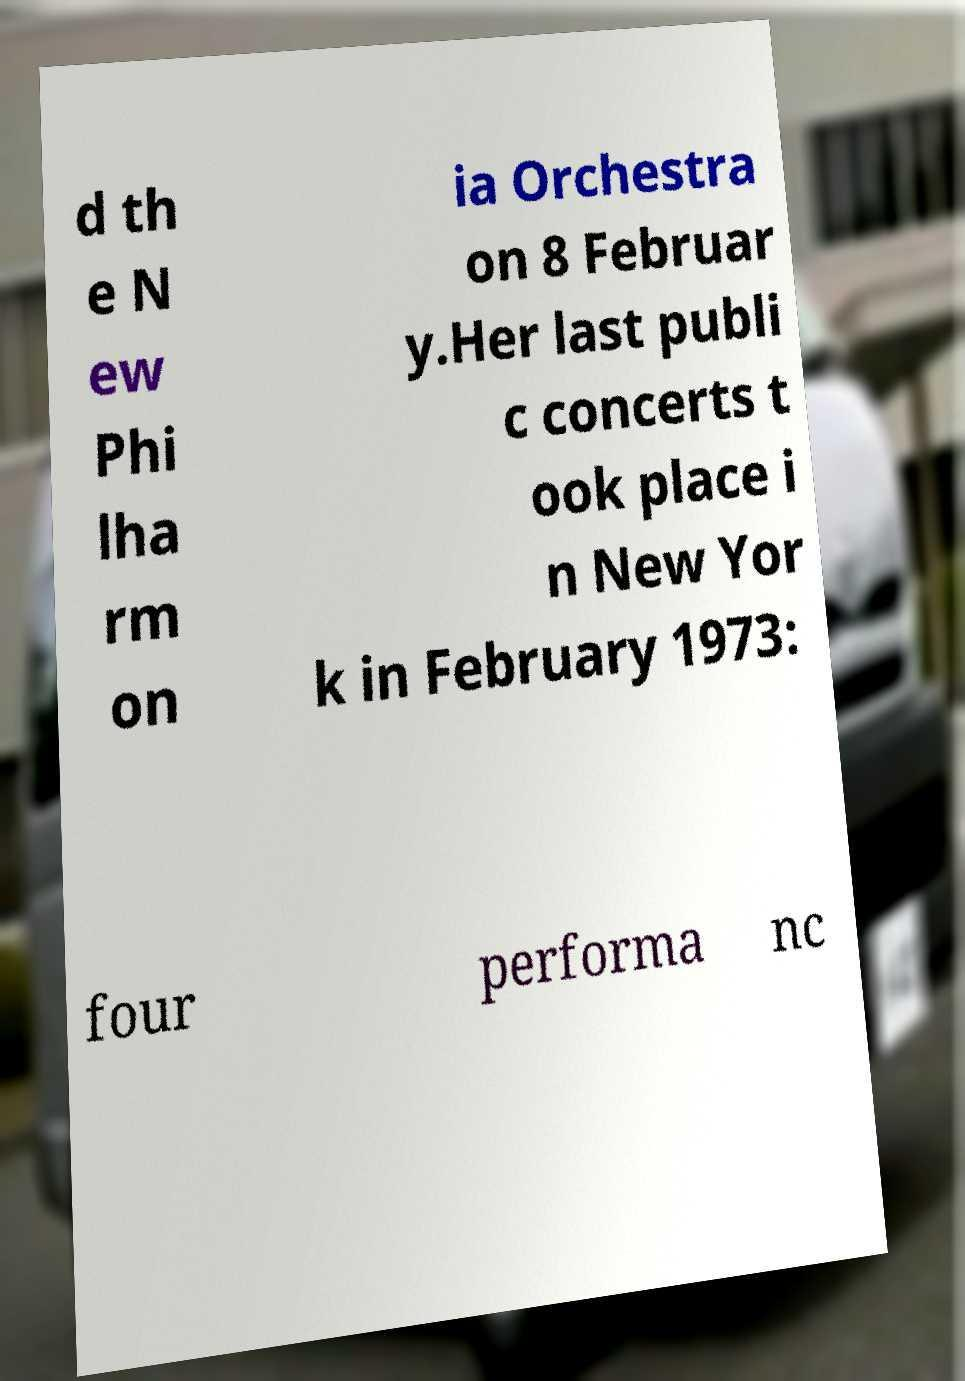Could you extract and type out the text from this image? d th e N ew Phi lha rm on ia Orchestra on 8 Februar y.Her last publi c concerts t ook place i n New Yor k in February 1973: four performa nc 